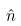<formula> <loc_0><loc_0><loc_500><loc_500>\hat { n }</formula> 